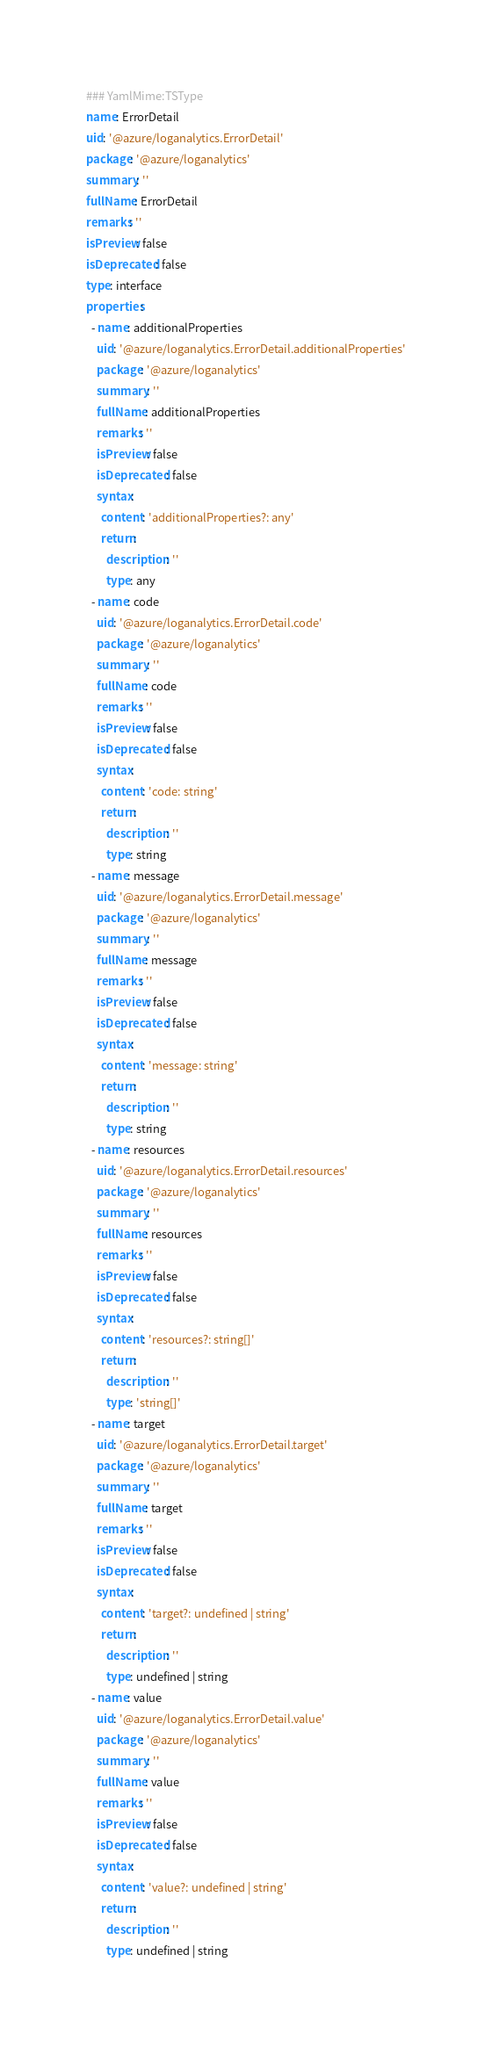<code> <loc_0><loc_0><loc_500><loc_500><_YAML_>### YamlMime:TSType
name: ErrorDetail
uid: '@azure/loganalytics.ErrorDetail'
package: '@azure/loganalytics'
summary: ''
fullName: ErrorDetail
remarks: ''
isPreview: false
isDeprecated: false
type: interface
properties:
  - name: additionalProperties
    uid: '@azure/loganalytics.ErrorDetail.additionalProperties'
    package: '@azure/loganalytics'
    summary: ''
    fullName: additionalProperties
    remarks: ''
    isPreview: false
    isDeprecated: false
    syntax:
      content: 'additionalProperties?: any'
      return:
        description: ''
        type: any
  - name: code
    uid: '@azure/loganalytics.ErrorDetail.code'
    package: '@azure/loganalytics'
    summary: ''
    fullName: code
    remarks: ''
    isPreview: false
    isDeprecated: false
    syntax:
      content: 'code: string'
      return:
        description: ''
        type: string
  - name: message
    uid: '@azure/loganalytics.ErrorDetail.message'
    package: '@azure/loganalytics'
    summary: ''
    fullName: message
    remarks: ''
    isPreview: false
    isDeprecated: false
    syntax:
      content: 'message: string'
      return:
        description: ''
        type: string
  - name: resources
    uid: '@azure/loganalytics.ErrorDetail.resources'
    package: '@azure/loganalytics'
    summary: ''
    fullName: resources
    remarks: ''
    isPreview: false
    isDeprecated: false
    syntax:
      content: 'resources?: string[]'
      return:
        description: ''
        type: 'string[]'
  - name: target
    uid: '@azure/loganalytics.ErrorDetail.target'
    package: '@azure/loganalytics'
    summary: ''
    fullName: target
    remarks: ''
    isPreview: false
    isDeprecated: false
    syntax:
      content: 'target?: undefined | string'
      return:
        description: ''
        type: undefined | string
  - name: value
    uid: '@azure/loganalytics.ErrorDetail.value'
    package: '@azure/loganalytics'
    summary: ''
    fullName: value
    remarks: ''
    isPreview: false
    isDeprecated: false
    syntax:
      content: 'value?: undefined | string'
      return:
        description: ''
        type: undefined | string
</code> 